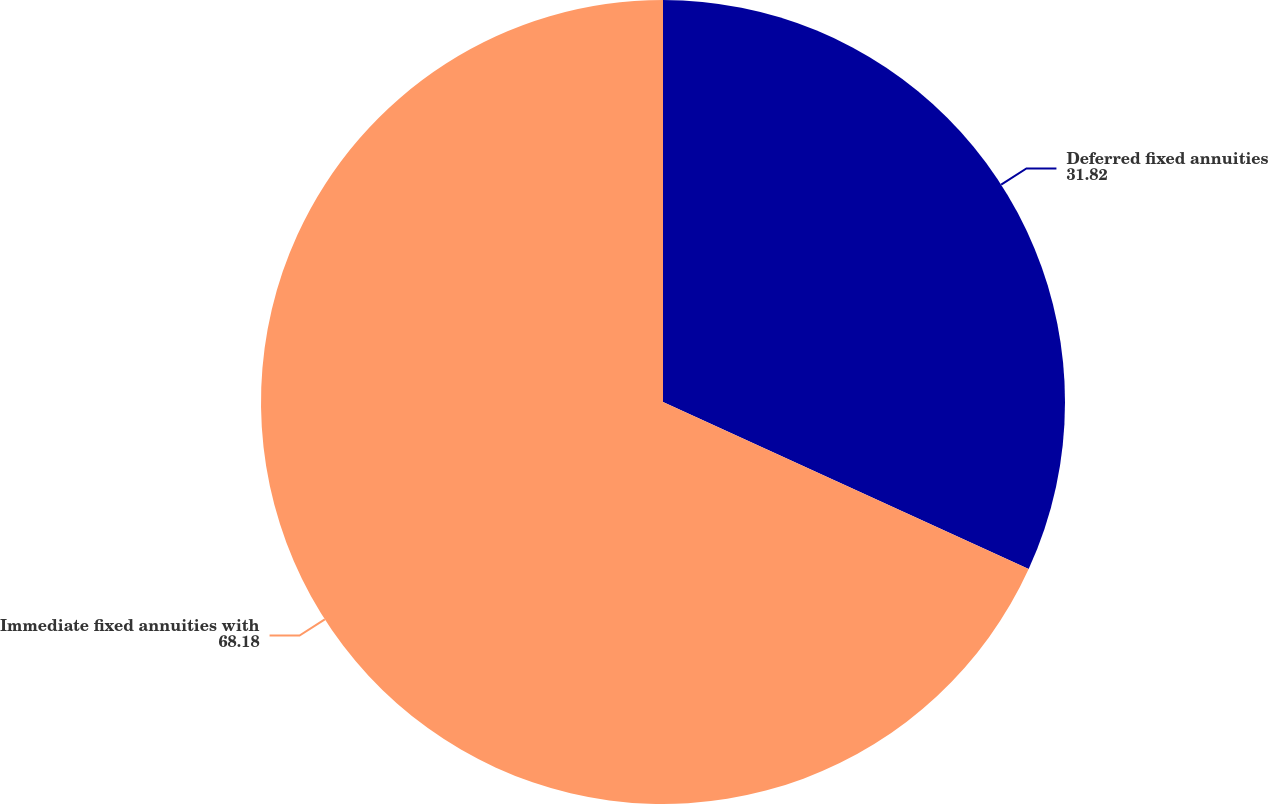Convert chart to OTSL. <chart><loc_0><loc_0><loc_500><loc_500><pie_chart><fcel>Deferred fixed annuities<fcel>Immediate fixed annuities with<nl><fcel>31.82%<fcel>68.18%<nl></chart> 